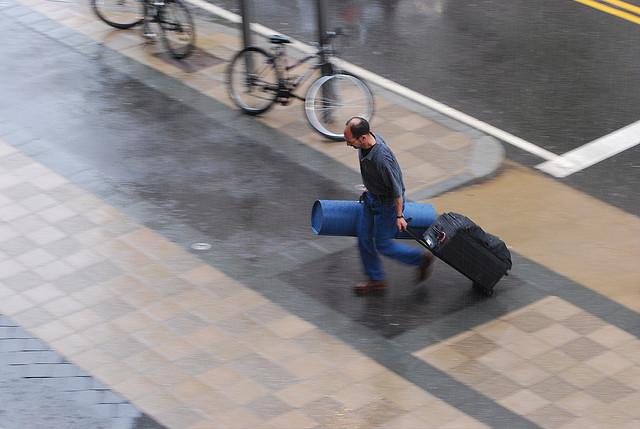What is this man holding?
Quick response, please. Luggage. Is the man going bald?
Be succinct. Yes. How many bicycles are shown?
Short answer required. 2. 